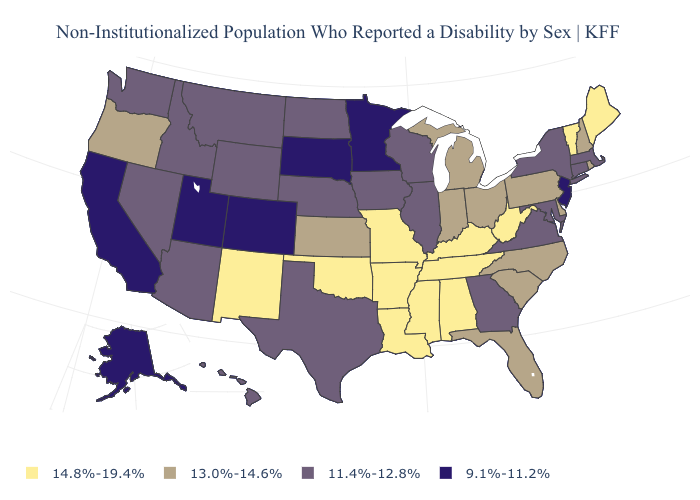What is the value of Connecticut?
Quick response, please. 11.4%-12.8%. Does the map have missing data?
Concise answer only. No. Does North Carolina have a higher value than Delaware?
Concise answer only. No. What is the value of Indiana?
Concise answer only. 13.0%-14.6%. Among the states that border Georgia , which have the highest value?
Short answer required. Alabama, Tennessee. Name the states that have a value in the range 13.0%-14.6%?
Answer briefly. Delaware, Florida, Indiana, Kansas, Michigan, New Hampshire, North Carolina, Ohio, Oregon, Pennsylvania, Rhode Island, South Carolina. Name the states that have a value in the range 9.1%-11.2%?
Short answer required. Alaska, California, Colorado, Minnesota, New Jersey, South Dakota, Utah. What is the highest value in states that border Texas?
Be succinct. 14.8%-19.4%. Which states have the highest value in the USA?
Quick response, please. Alabama, Arkansas, Kentucky, Louisiana, Maine, Mississippi, Missouri, New Mexico, Oklahoma, Tennessee, Vermont, West Virginia. Among the states that border Kansas , which have the lowest value?
Answer briefly. Colorado. What is the value of Florida?
Give a very brief answer. 13.0%-14.6%. Does New Mexico have the highest value in the West?
Write a very short answer. Yes. Among the states that border Connecticut , does Massachusetts have the lowest value?
Answer briefly. Yes. What is the value of Florida?
Write a very short answer. 13.0%-14.6%. Name the states that have a value in the range 13.0%-14.6%?
Keep it brief. Delaware, Florida, Indiana, Kansas, Michigan, New Hampshire, North Carolina, Ohio, Oregon, Pennsylvania, Rhode Island, South Carolina. 